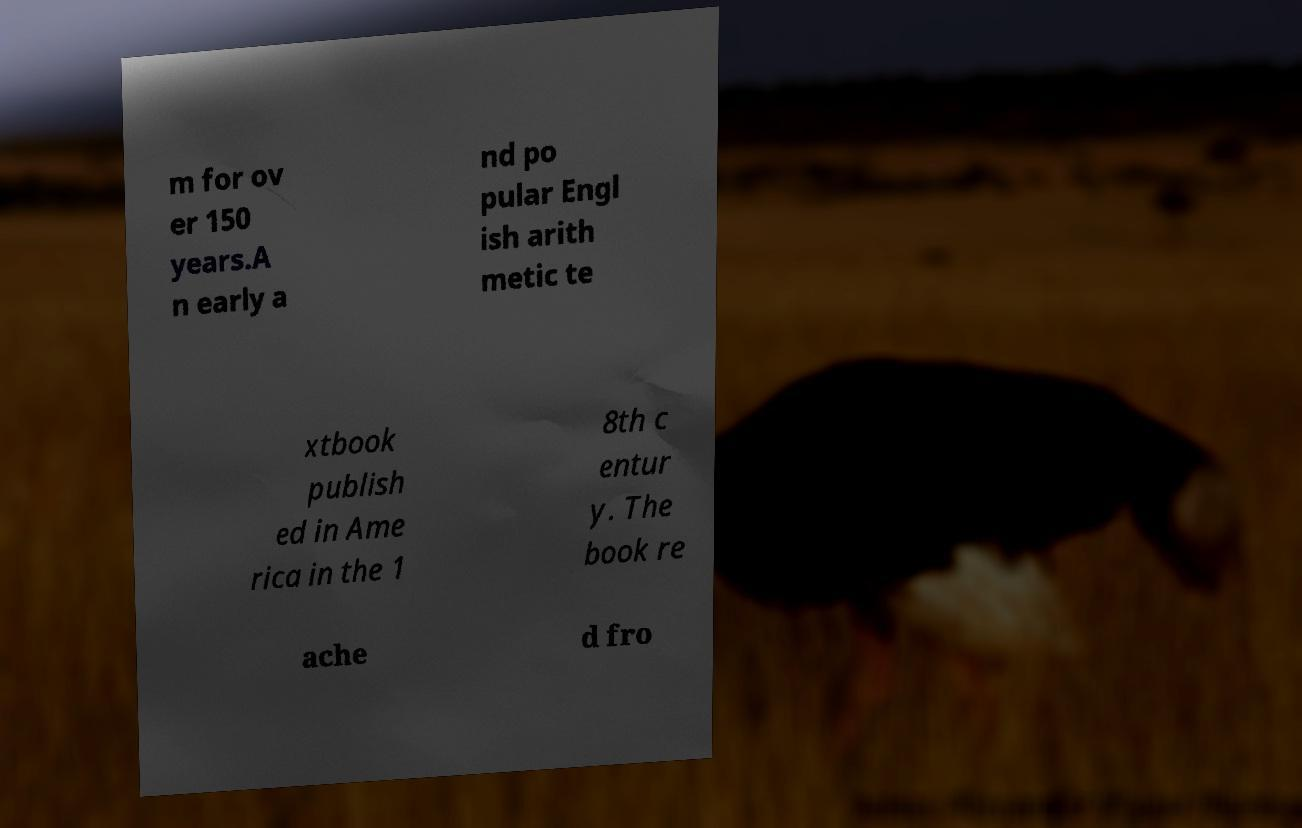I need the written content from this picture converted into text. Can you do that? m for ov er 150 years.A n early a nd po pular Engl ish arith metic te xtbook publish ed in Ame rica in the 1 8th c entur y. The book re ache d fro 